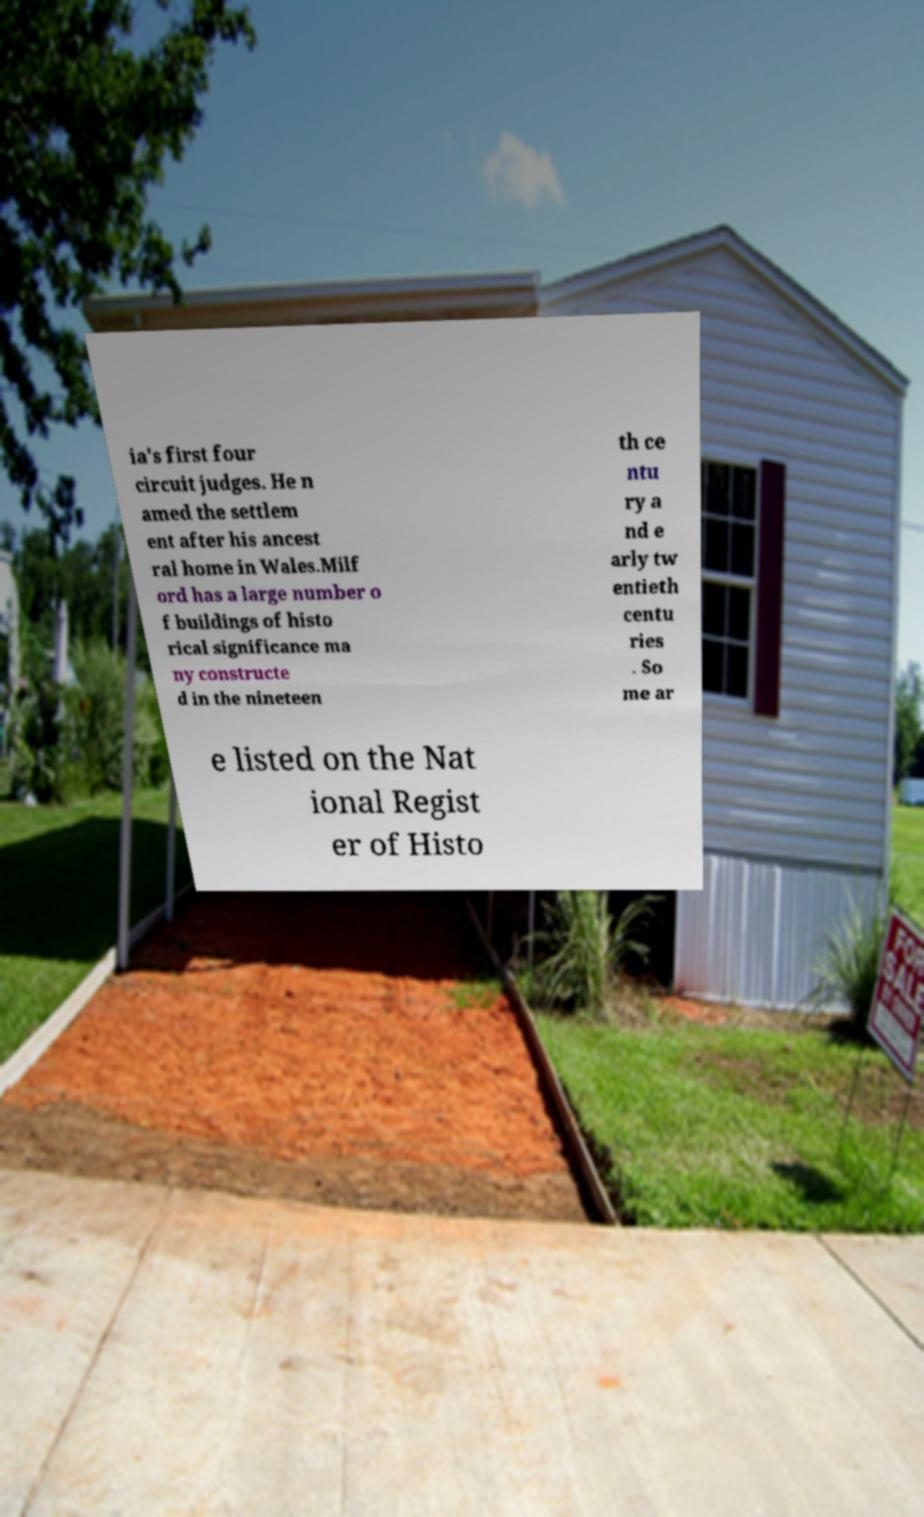Could you assist in decoding the text presented in this image and type it out clearly? ia's first four circuit judges. He n amed the settlem ent after his ancest ral home in Wales.Milf ord has a large number o f buildings of histo rical significance ma ny constructe d in the nineteen th ce ntu ry a nd e arly tw entieth centu ries . So me ar e listed on the Nat ional Regist er of Histo 